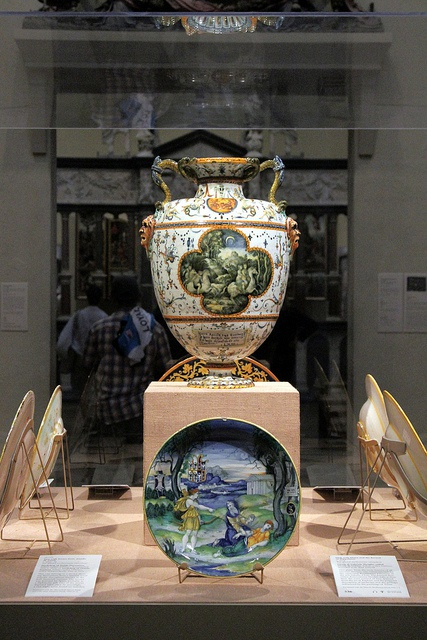Describe the objects in this image and their specific colors. I can see dining table in gray, tan, and lightgray tones, vase in gray, white, black, and darkgray tones, people in gray and black tones, and people in gray and black tones in this image. 